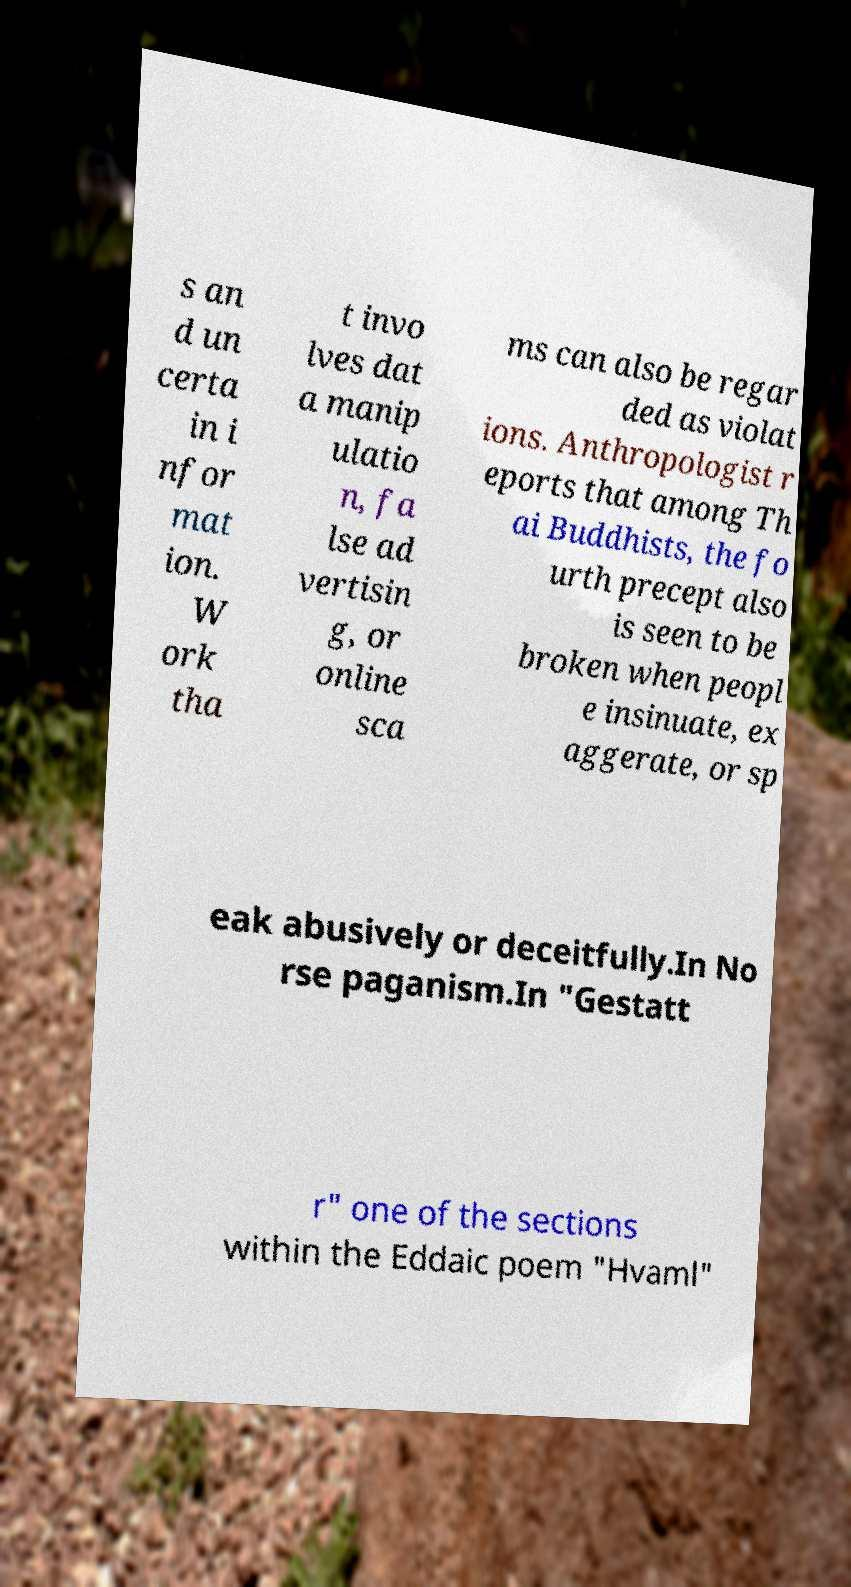I need the written content from this picture converted into text. Can you do that? s an d un certa in i nfor mat ion. W ork tha t invo lves dat a manip ulatio n, fa lse ad vertisin g, or online sca ms can also be regar ded as violat ions. Anthropologist r eports that among Th ai Buddhists, the fo urth precept also is seen to be broken when peopl e insinuate, ex aggerate, or sp eak abusively or deceitfully.In No rse paganism.In "Gestatt r" one of the sections within the Eddaic poem "Hvaml" 